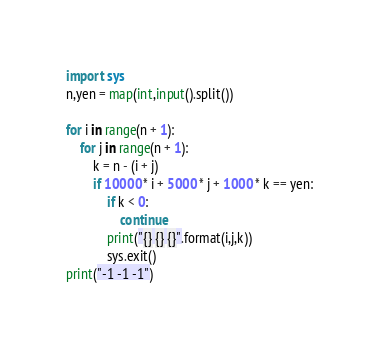<code> <loc_0><loc_0><loc_500><loc_500><_Python_>import sys
n,yen = map(int,input().split())

for i in range(n + 1):
    for j in range(n + 1):
        k = n - (i + j)
        if 10000 * i + 5000 * j + 1000 * k == yen:
            if k < 0:
                continue
            print("{} {} {}".format(i,j,k))
            sys.exit()
print("-1 -1 -1")</code> 